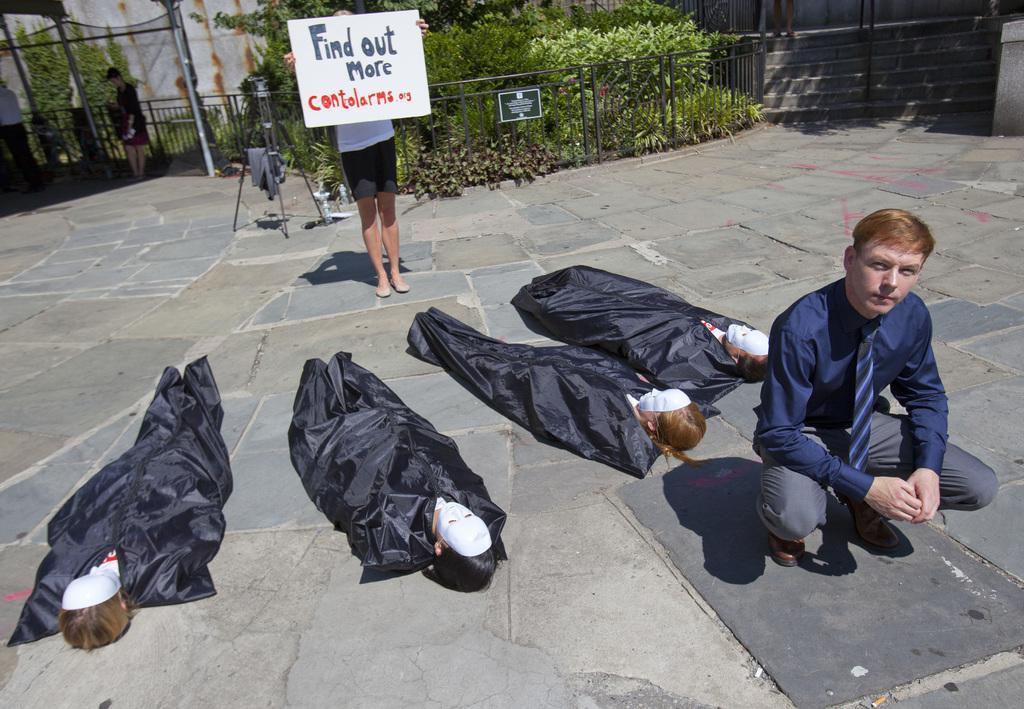Could you give a brief overview of what you see in this image? In the image we can see there are four people lying, they are wearing face masks and they are covered with black color cloth. Here we can see a man and a woman and the woman poster in her hand. Here we can see fence, plants, pole and the footpath. 